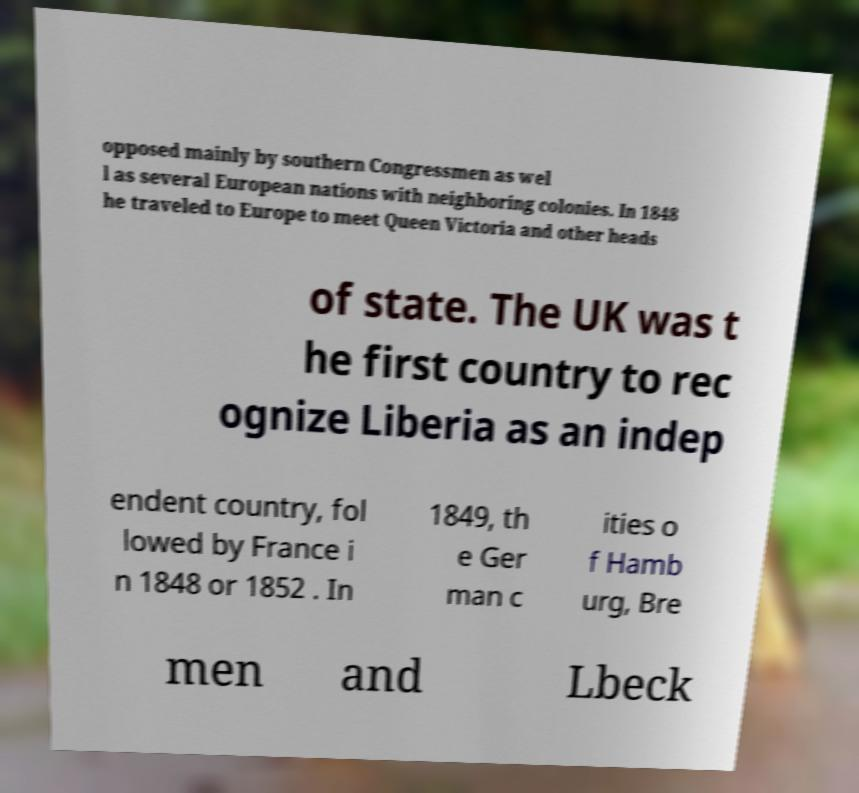For documentation purposes, I need the text within this image transcribed. Could you provide that? opposed mainly by southern Congressmen as wel l as several European nations with neighboring colonies. In 1848 he traveled to Europe to meet Queen Victoria and other heads of state. The UK was t he first country to rec ognize Liberia as an indep endent country, fol lowed by France i n 1848 or 1852 . In 1849, th e Ger man c ities o f Hamb urg, Bre men and Lbeck 